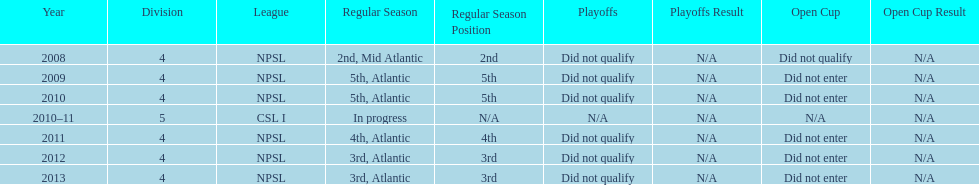In what year only did they compete in division 5 2010-11. 